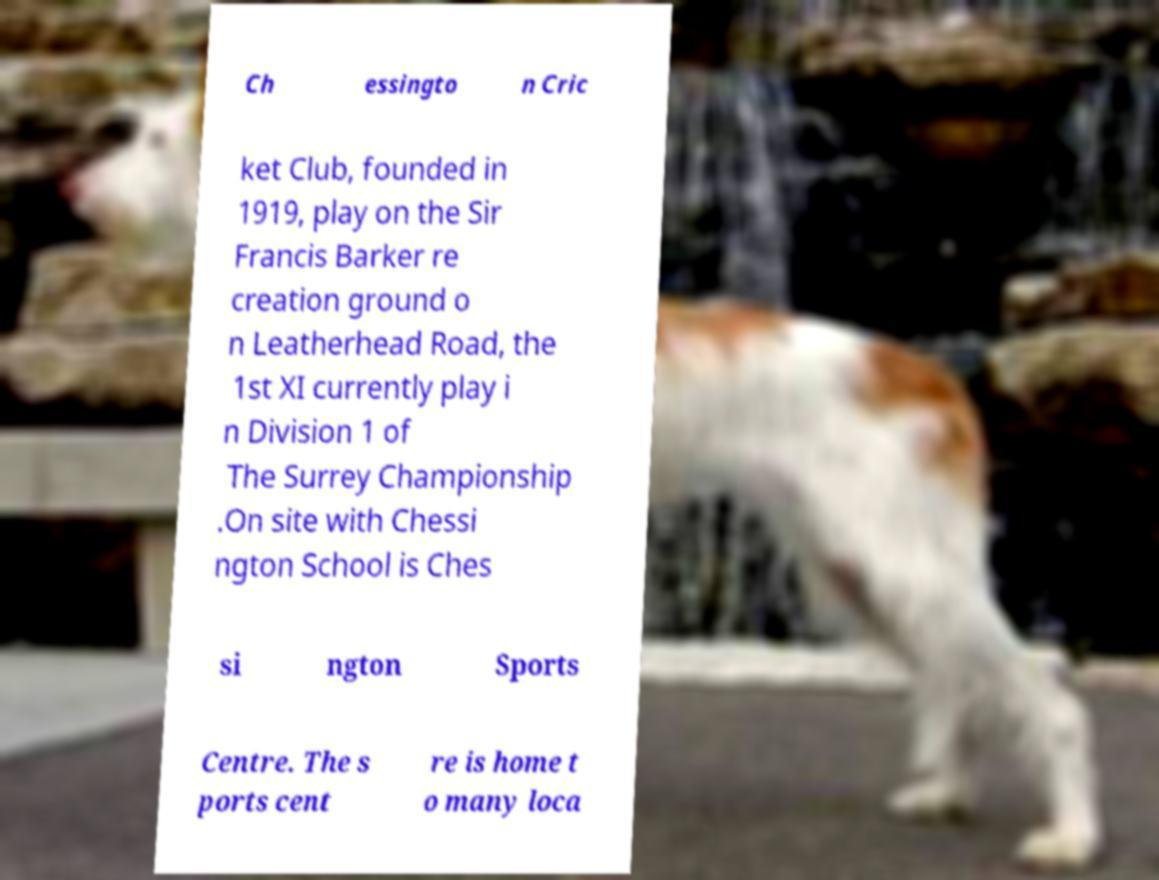For documentation purposes, I need the text within this image transcribed. Could you provide that? Ch essingto n Cric ket Club, founded in 1919, play on the Sir Francis Barker re creation ground o n Leatherhead Road, the 1st XI currently play i n Division 1 of The Surrey Championship .On site with Chessi ngton School is Ches si ngton Sports Centre. The s ports cent re is home t o many loca 